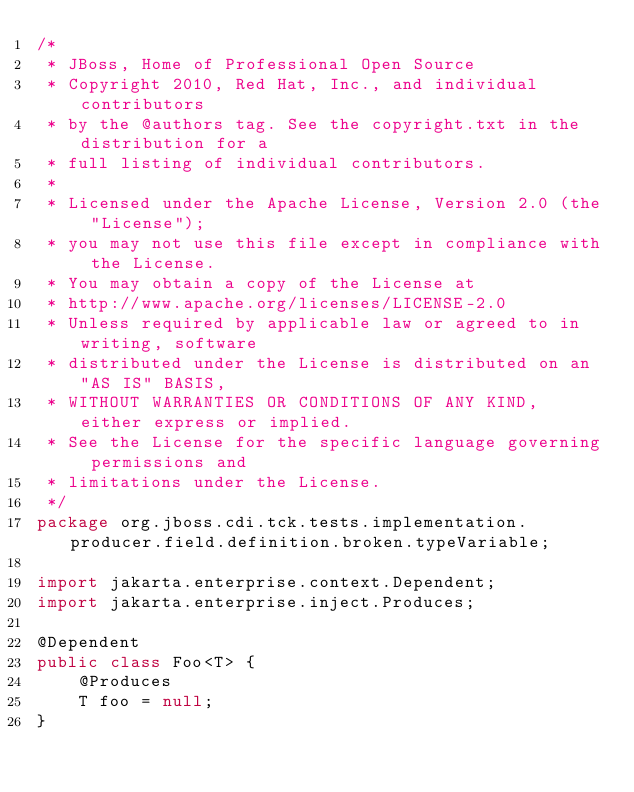Convert code to text. <code><loc_0><loc_0><loc_500><loc_500><_Java_>/*
 * JBoss, Home of Professional Open Source
 * Copyright 2010, Red Hat, Inc., and individual contributors
 * by the @authors tag. See the copyright.txt in the distribution for a
 * full listing of individual contributors.
 *
 * Licensed under the Apache License, Version 2.0 (the "License");
 * you may not use this file except in compliance with the License.
 * You may obtain a copy of the License at
 * http://www.apache.org/licenses/LICENSE-2.0
 * Unless required by applicable law or agreed to in writing, software
 * distributed under the License is distributed on an "AS IS" BASIS,  
 * WITHOUT WARRANTIES OR CONDITIONS OF ANY KIND, either express or implied.
 * See the License for the specific language governing permissions and
 * limitations under the License.
 */
package org.jboss.cdi.tck.tests.implementation.producer.field.definition.broken.typeVariable;

import jakarta.enterprise.context.Dependent;
import jakarta.enterprise.inject.Produces;

@Dependent
public class Foo<T> {
    @Produces
    T foo = null;
}
</code> 